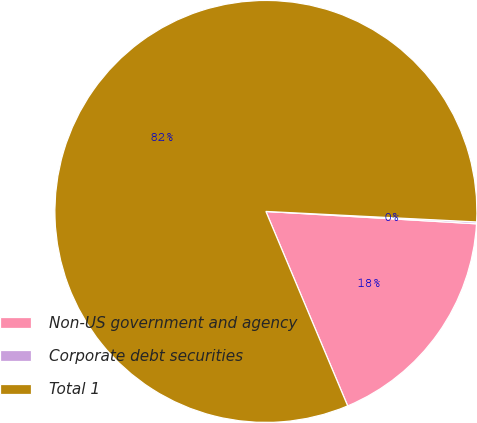Convert chart to OTSL. <chart><loc_0><loc_0><loc_500><loc_500><pie_chart><fcel>Non-US government and agency<fcel>Corporate debt securities<fcel>Total 1<nl><fcel>17.73%<fcel>0.14%<fcel>82.13%<nl></chart> 